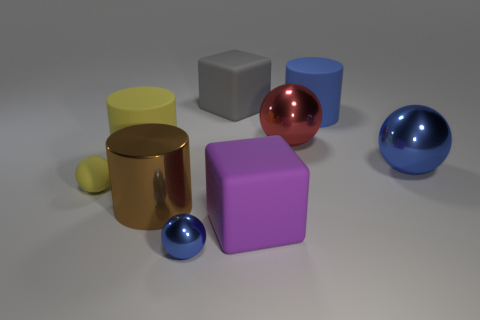The shiny thing that is the same color as the small metallic sphere is what shape? sphere 